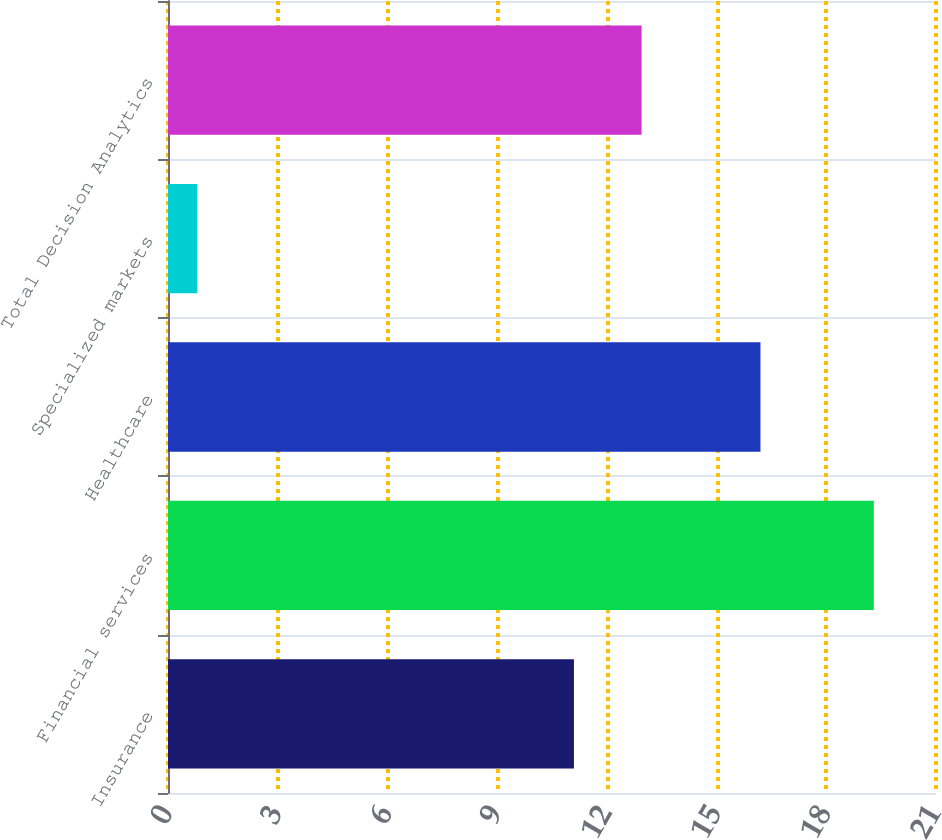<chart> <loc_0><loc_0><loc_500><loc_500><bar_chart><fcel>Insurance<fcel>Financial services<fcel>Healthcare<fcel>Specialized markets<fcel>Total Decision Analytics<nl><fcel>11.1<fcel>19.3<fcel>16.2<fcel>0.8<fcel>12.95<nl></chart> 